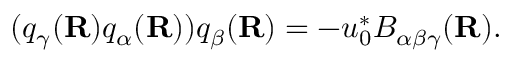<formula> <loc_0><loc_0><loc_500><loc_500>( q _ { \gamma } ( { R } ) q _ { \alpha } ( { R } ) ) q _ { \beta } ( { R } ) = - u _ { 0 } ^ { * } B _ { \alpha \beta \gamma } ( { R } ) .</formula> 